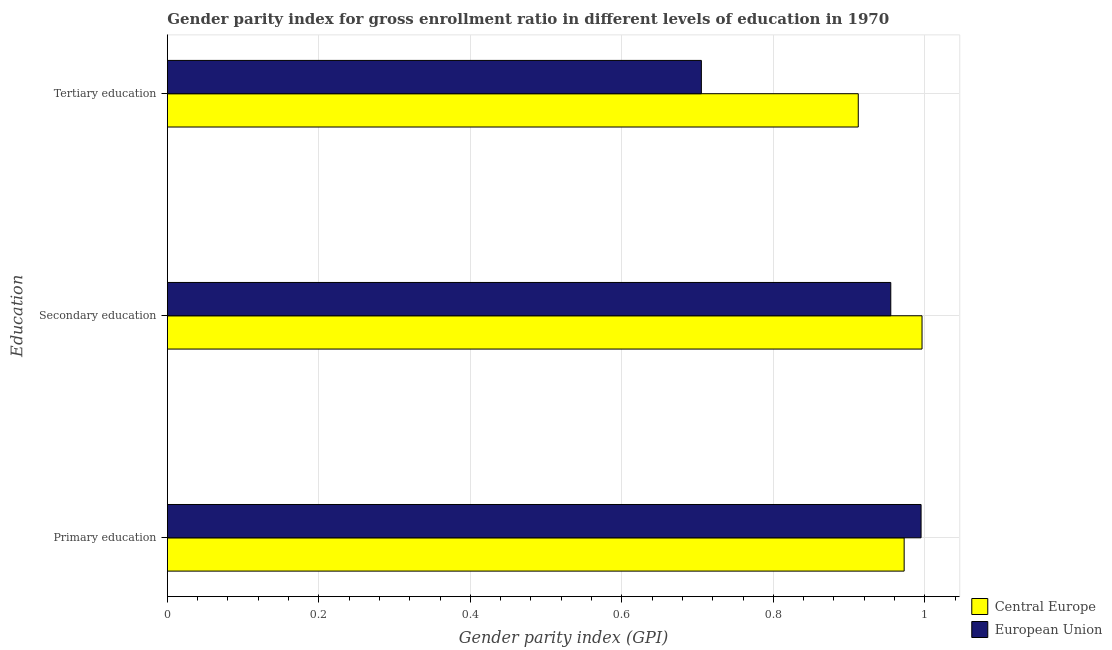How many different coloured bars are there?
Give a very brief answer. 2. How many groups of bars are there?
Provide a short and direct response. 3. Are the number of bars on each tick of the Y-axis equal?
Make the answer very short. Yes. What is the label of the 3rd group of bars from the top?
Give a very brief answer. Primary education. What is the gender parity index in secondary education in Central Europe?
Give a very brief answer. 1. Across all countries, what is the maximum gender parity index in primary education?
Ensure brevity in your answer.  1. Across all countries, what is the minimum gender parity index in secondary education?
Ensure brevity in your answer.  0.96. In which country was the gender parity index in secondary education maximum?
Your answer should be compact. Central Europe. What is the total gender parity index in primary education in the graph?
Keep it short and to the point. 1.97. What is the difference between the gender parity index in secondary education in Central Europe and that in European Union?
Make the answer very short. 0.04. What is the difference between the gender parity index in primary education in Central Europe and the gender parity index in secondary education in European Union?
Your response must be concise. 0.02. What is the average gender parity index in tertiary education per country?
Your answer should be very brief. 0.81. What is the difference between the gender parity index in secondary education and gender parity index in tertiary education in European Union?
Your answer should be very brief. 0.25. What is the ratio of the gender parity index in tertiary education in European Union to that in Central Europe?
Your answer should be compact. 0.77. Is the gender parity index in secondary education in Central Europe less than that in European Union?
Give a very brief answer. No. What is the difference between the highest and the second highest gender parity index in tertiary education?
Keep it short and to the point. 0.21. What is the difference between the highest and the lowest gender parity index in secondary education?
Give a very brief answer. 0.04. How many countries are there in the graph?
Your response must be concise. 2. Does the graph contain grids?
Provide a succinct answer. Yes. Where does the legend appear in the graph?
Give a very brief answer. Bottom right. How many legend labels are there?
Offer a terse response. 2. What is the title of the graph?
Provide a succinct answer. Gender parity index for gross enrollment ratio in different levels of education in 1970. Does "Turkmenistan" appear as one of the legend labels in the graph?
Your answer should be compact. No. What is the label or title of the X-axis?
Offer a very short reply. Gender parity index (GPI). What is the label or title of the Y-axis?
Make the answer very short. Education. What is the Gender parity index (GPI) of Central Europe in Primary education?
Ensure brevity in your answer.  0.97. What is the Gender parity index (GPI) in European Union in Primary education?
Your answer should be compact. 1. What is the Gender parity index (GPI) in Central Europe in Secondary education?
Provide a succinct answer. 1. What is the Gender parity index (GPI) of European Union in Secondary education?
Ensure brevity in your answer.  0.96. What is the Gender parity index (GPI) in Central Europe in Tertiary education?
Provide a short and direct response. 0.91. What is the Gender parity index (GPI) of European Union in Tertiary education?
Offer a very short reply. 0.71. Across all Education, what is the maximum Gender parity index (GPI) of Central Europe?
Ensure brevity in your answer.  1. Across all Education, what is the maximum Gender parity index (GPI) in European Union?
Offer a very short reply. 1. Across all Education, what is the minimum Gender parity index (GPI) in Central Europe?
Offer a terse response. 0.91. Across all Education, what is the minimum Gender parity index (GPI) in European Union?
Provide a short and direct response. 0.71. What is the total Gender parity index (GPI) in Central Europe in the graph?
Ensure brevity in your answer.  2.88. What is the total Gender parity index (GPI) of European Union in the graph?
Your answer should be very brief. 2.66. What is the difference between the Gender parity index (GPI) in Central Europe in Primary education and that in Secondary education?
Your answer should be very brief. -0.02. What is the difference between the Gender parity index (GPI) of European Union in Primary education and that in Secondary education?
Offer a terse response. 0.04. What is the difference between the Gender parity index (GPI) in Central Europe in Primary education and that in Tertiary education?
Your response must be concise. 0.06. What is the difference between the Gender parity index (GPI) of European Union in Primary education and that in Tertiary education?
Offer a very short reply. 0.29. What is the difference between the Gender parity index (GPI) of Central Europe in Secondary education and that in Tertiary education?
Offer a very short reply. 0.08. What is the difference between the Gender parity index (GPI) of European Union in Secondary education and that in Tertiary education?
Offer a terse response. 0.25. What is the difference between the Gender parity index (GPI) in Central Europe in Primary education and the Gender parity index (GPI) in European Union in Secondary education?
Offer a very short reply. 0.02. What is the difference between the Gender parity index (GPI) of Central Europe in Primary education and the Gender parity index (GPI) of European Union in Tertiary education?
Keep it short and to the point. 0.27. What is the difference between the Gender parity index (GPI) of Central Europe in Secondary education and the Gender parity index (GPI) of European Union in Tertiary education?
Ensure brevity in your answer.  0.29. What is the average Gender parity index (GPI) in Central Europe per Education?
Your answer should be very brief. 0.96. What is the average Gender parity index (GPI) in European Union per Education?
Offer a terse response. 0.89. What is the difference between the Gender parity index (GPI) in Central Europe and Gender parity index (GPI) in European Union in Primary education?
Provide a succinct answer. -0.02. What is the difference between the Gender parity index (GPI) in Central Europe and Gender parity index (GPI) in European Union in Secondary education?
Offer a very short reply. 0.04. What is the difference between the Gender parity index (GPI) of Central Europe and Gender parity index (GPI) of European Union in Tertiary education?
Provide a short and direct response. 0.21. What is the ratio of the Gender parity index (GPI) of Central Europe in Primary education to that in Secondary education?
Ensure brevity in your answer.  0.98. What is the ratio of the Gender parity index (GPI) of European Union in Primary education to that in Secondary education?
Provide a short and direct response. 1.04. What is the ratio of the Gender parity index (GPI) in Central Europe in Primary education to that in Tertiary education?
Offer a terse response. 1.07. What is the ratio of the Gender parity index (GPI) in European Union in Primary education to that in Tertiary education?
Give a very brief answer. 1.41. What is the ratio of the Gender parity index (GPI) in Central Europe in Secondary education to that in Tertiary education?
Keep it short and to the point. 1.09. What is the ratio of the Gender parity index (GPI) in European Union in Secondary education to that in Tertiary education?
Offer a terse response. 1.35. What is the difference between the highest and the second highest Gender parity index (GPI) of Central Europe?
Ensure brevity in your answer.  0.02. What is the difference between the highest and the lowest Gender parity index (GPI) in Central Europe?
Offer a terse response. 0.08. What is the difference between the highest and the lowest Gender parity index (GPI) in European Union?
Your response must be concise. 0.29. 